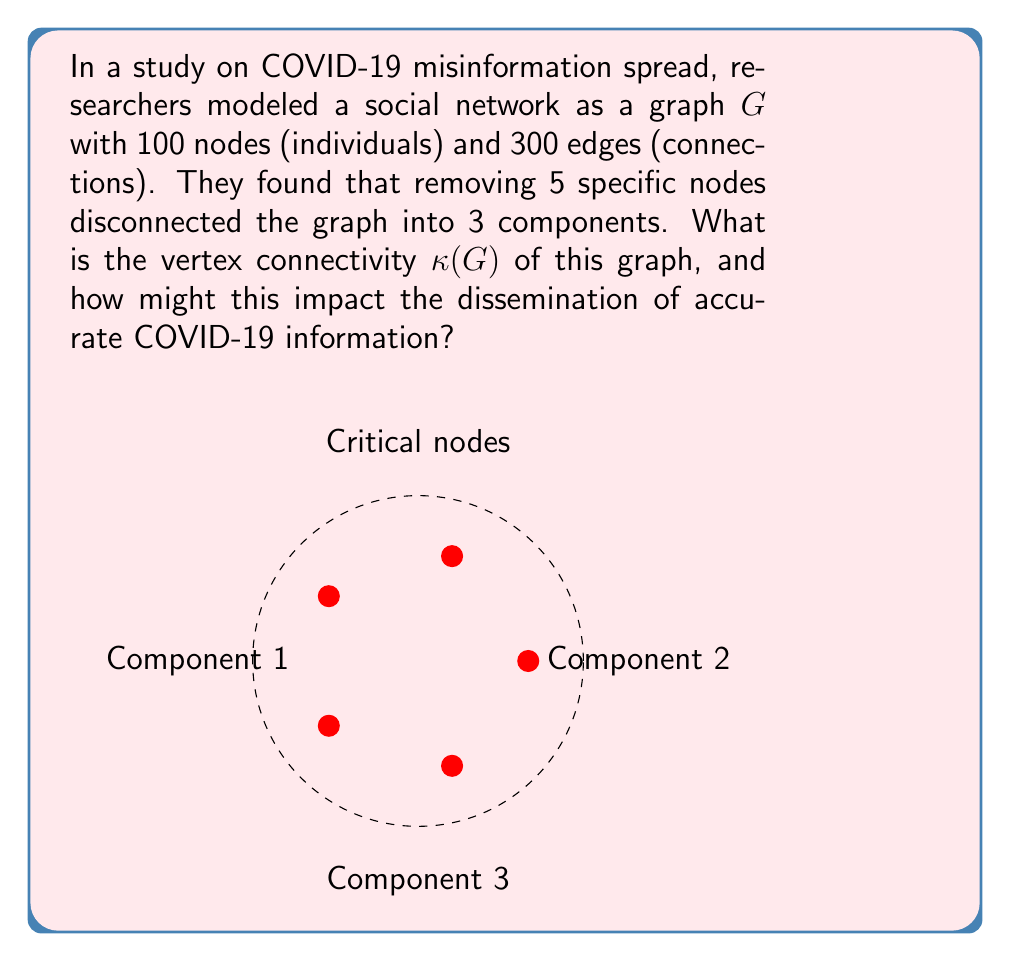Give your solution to this math problem. To solve this problem, we need to understand the concept of vertex connectivity and its implications for information dissemination:

1) Vertex connectivity $\kappa(G)$ is defined as the minimum number of vertices whose removal disconnects the graph.

2) In this case, removing 5 specific nodes disconnects the graph into 3 components. This means:
   $$\kappa(G) \leq 5$$

3) However, we need to verify if 5 is indeed the minimum. Since removing these 5 nodes is sufficient to disconnect the graph, and no smaller number is mentioned, we can conclude:
   $$\kappa(G) = 5$$

4) Impact on information dissemination:
   a) A lower $\kappa(G)$ indicates a more vulnerable network structure.
   b) With $\kappa(G) = 5$, the network has some resilience, but is still susceptible to disconnection.
   c) If these 5 critical nodes are removed (e.g., accounts closed), the network splits into 3 isolated components.
   d) This fragmentation would significantly hinder the spread of accurate COVID-19 information across the entire network.
   e) It also identifies key individuals or nodes that are crucial for maintaining network connectivity and information flow.

5) For public health communication:
   a) Focus on these critical nodes to spread accurate information efficiently.
   b) Develop strategies to increase network connectivity to make it more resilient against misinformation.
Answer: $\kappa(G) = 5$; Low connectivity increases vulnerability to misinformation spread and hinders dissemination of accurate COVID-19 information. 